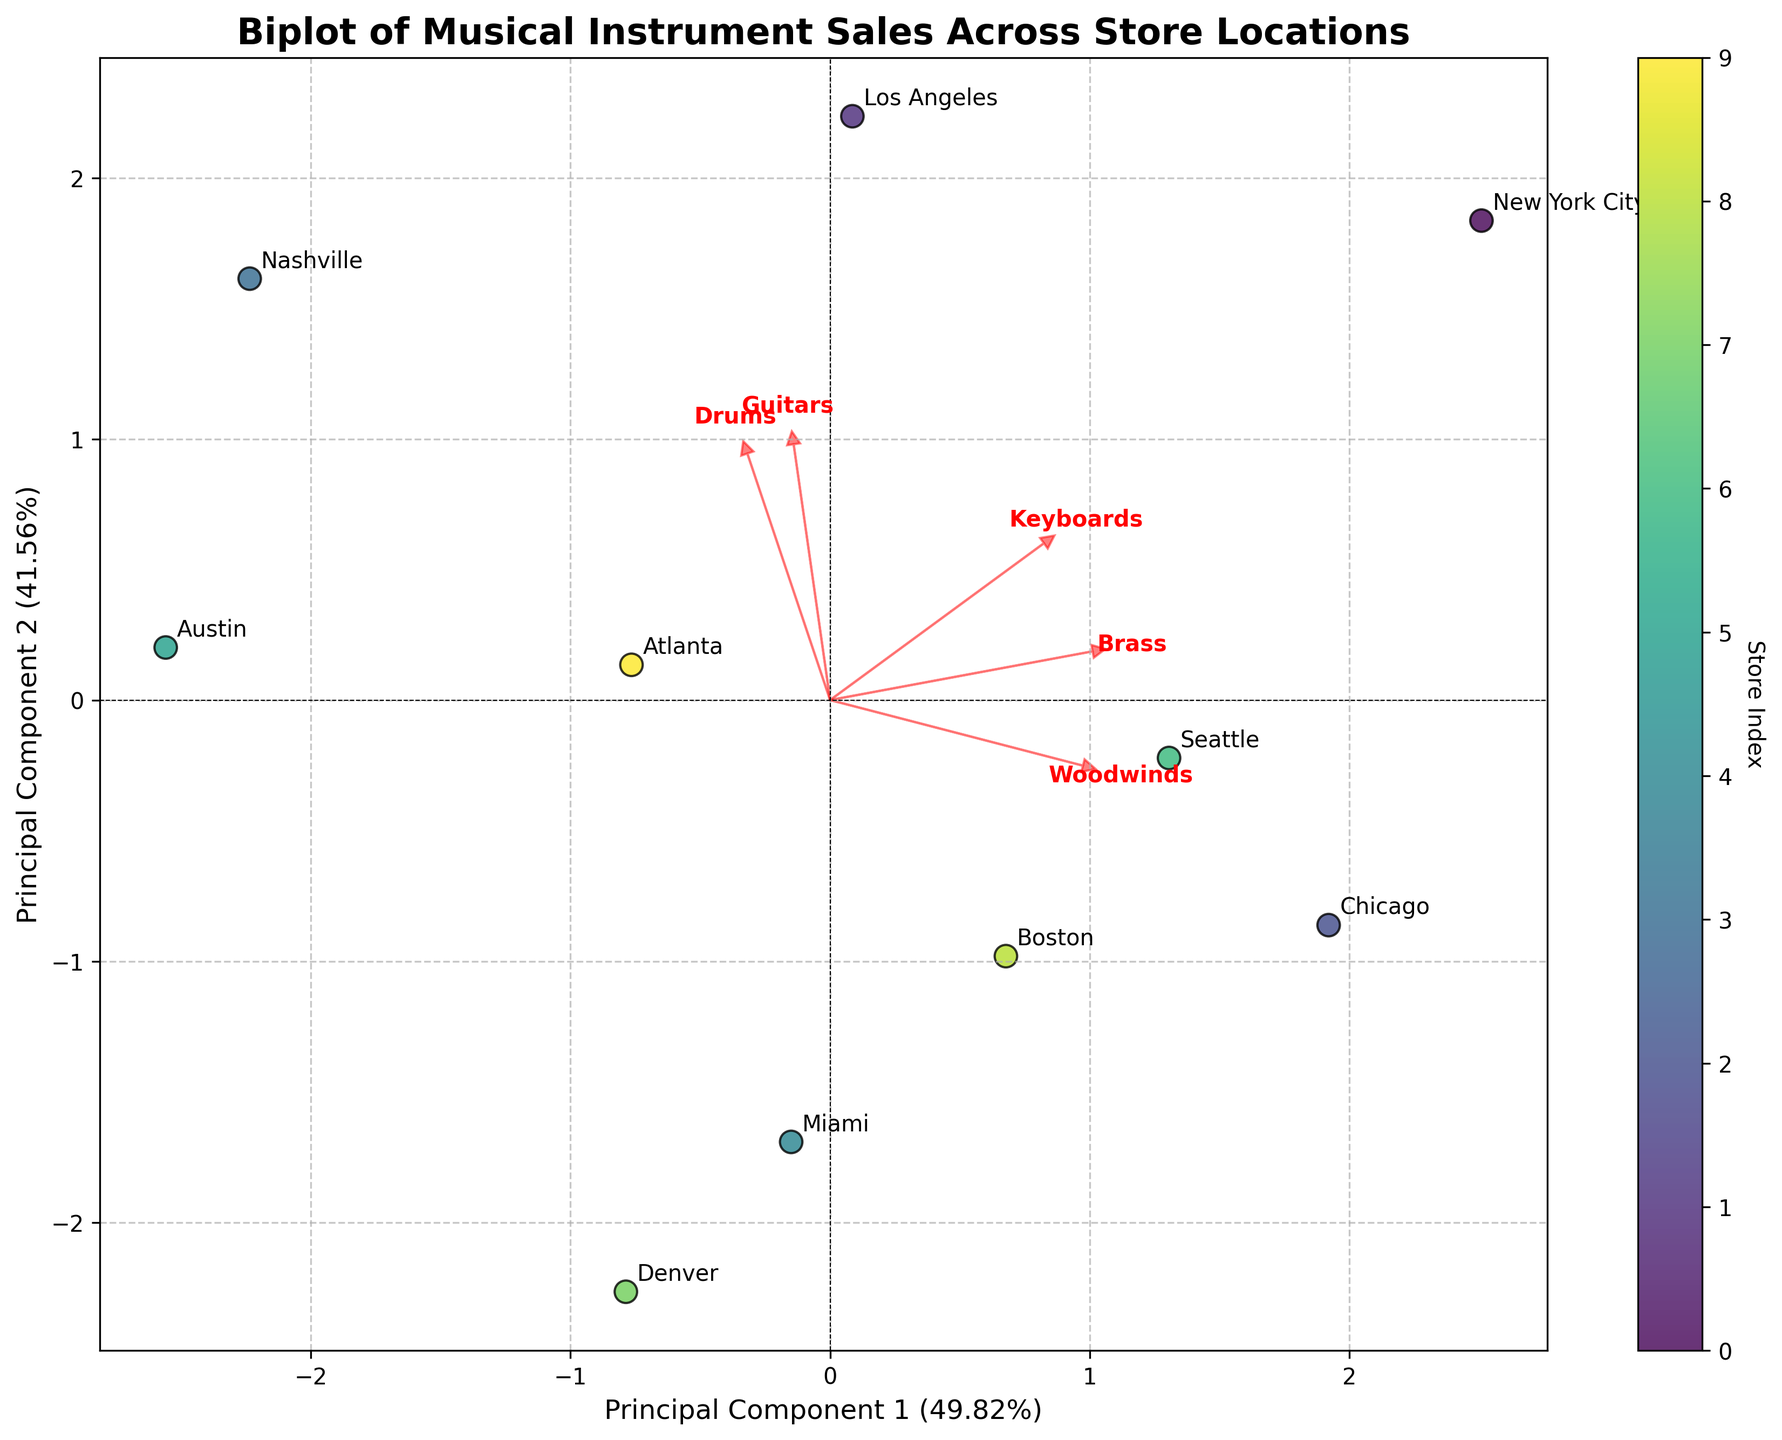What's the title of the biplot? Look at the top part of the plot for the text that summarizes the main subject of the figure.
Answer: Biplot of Musical Instrument Sales Across Store Locations How many principal components are used in this plot? Observe the labels on the x and y axes which indicate "Principal Component 1" and "Principal Component 2".
Answer: Two What store is positioned farthest to the right on the biplot? Check the relative position of the store labels on the biplot, specifically looking at the rightmost side.
Answer: New York City Which musical instrument has the highest loading on Principal Component 1? Identify the arrows representing loadings and observe their direction and length; the instrument with the longest arrow in the direction of Principal Component 1 has the highest loading.
Answer: Guitars Which store has the highest sales in Guitars based on the biplot positioning? Look at the positions of store labels in relation to the arrow representing Guitars, and find the store closest to the tip of the Guitar arrow.
Answer: Nashville What does the color bar in the biplot represent? Notice the color gradient and its label, which indicates what the colors correspond to.
Answer: Store Index Which store has the most balanced sales among the various instrument categories? Examine the distribution of store labels around the center of the plot, which indicates balanced sales.
Answer: Seattle What percentage of the total variance is explained by the first two principal components? Look at the axis labels which include the percentage of variance explained by Principal Component 1 and Principal Component 2.
Answer: PC1: 54.26%, PC2: 28.19% How do the sales of Brass and Woodwinds compare across the different stores? Find the arrows representing Brass and Woodwinds, and observe their positioning relative to the store labels. Check which stores are near the tips of both arrows or neither of them.
Answer: Generally, stores like Chicago and Miami have moderate performances in both Which store has the lowest sales in Brass? Look for the store label that is furthest from the direction of the Brass arrow.
Answer: Nashville 